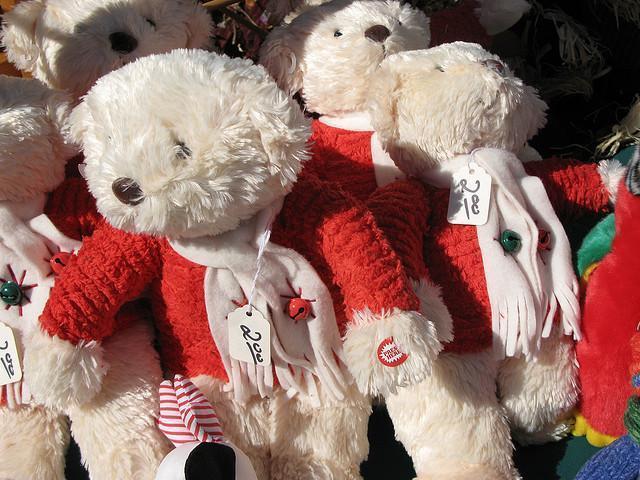How many bear noses are in the picture?
Give a very brief answer. 4. How many teddy bears can be seen?
Give a very brief answer. 4. How many clocks can be seen?
Give a very brief answer. 0. 